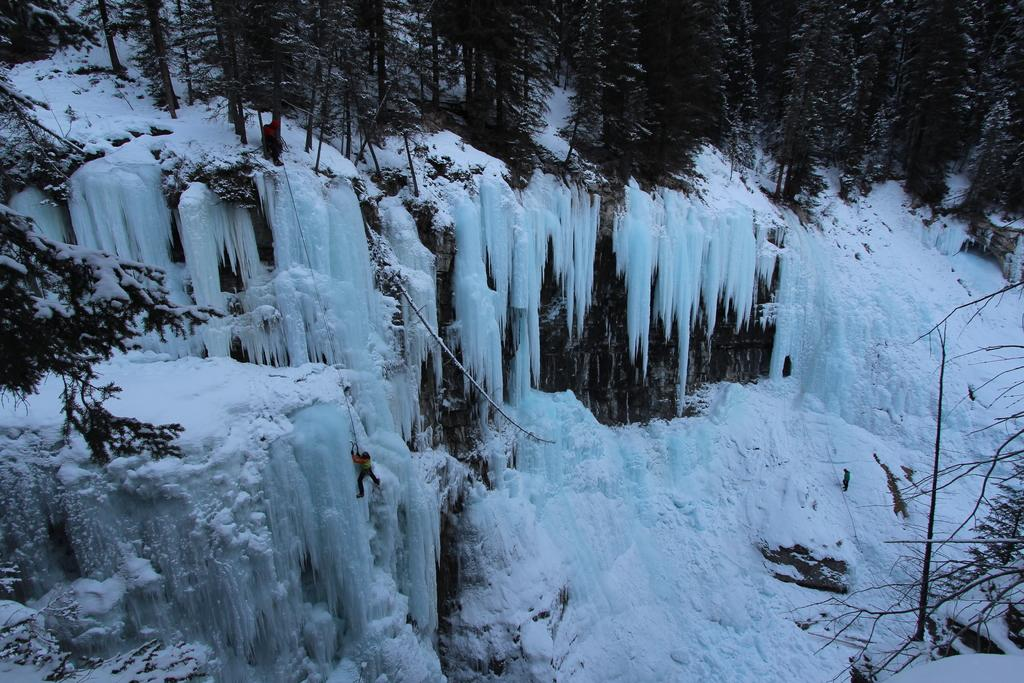What type of weather condition is depicted in the image? There is snow on a mountain in the image, indicating a cold or snowy weather condition. Where is the main subject of the image located? The mountain is in the middle of the image. What can be seen at the top of the mountain in the image? There are trees at the top of the mountain in the image. Are there any fairies flying around the trees at the top of the mountain in the image? There is no indication of fairies or any other mythical creatures in the image; it only depicts a snowy mountain with trees at the top. 